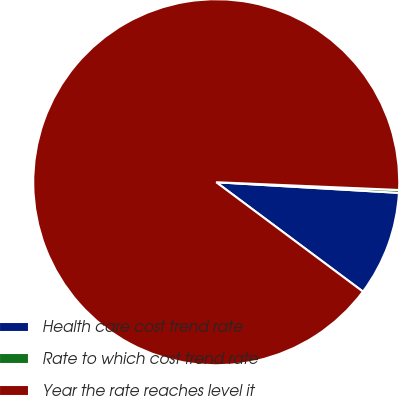<chart> <loc_0><loc_0><loc_500><loc_500><pie_chart><fcel>Health care cost trend rate<fcel>Rate to which cost trend rate<fcel>Year the rate reaches level it<nl><fcel>9.27%<fcel>0.25%<fcel>90.48%<nl></chart> 